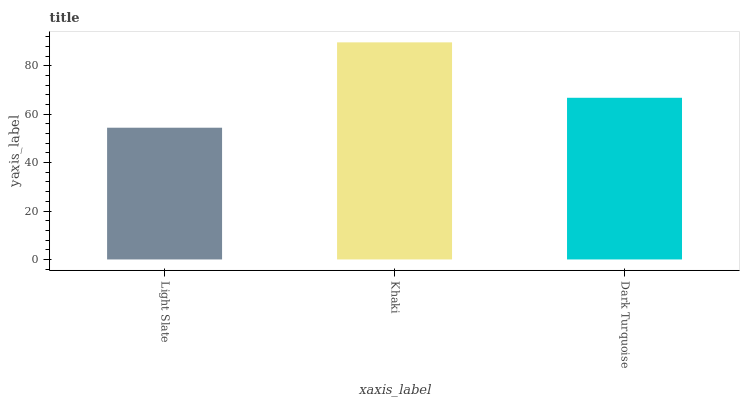Is Light Slate the minimum?
Answer yes or no. Yes. Is Khaki the maximum?
Answer yes or no. Yes. Is Dark Turquoise the minimum?
Answer yes or no. No. Is Dark Turquoise the maximum?
Answer yes or no. No. Is Khaki greater than Dark Turquoise?
Answer yes or no. Yes. Is Dark Turquoise less than Khaki?
Answer yes or no. Yes. Is Dark Turquoise greater than Khaki?
Answer yes or no. No. Is Khaki less than Dark Turquoise?
Answer yes or no. No. Is Dark Turquoise the high median?
Answer yes or no. Yes. Is Dark Turquoise the low median?
Answer yes or no. Yes. Is Light Slate the high median?
Answer yes or no. No. Is Light Slate the low median?
Answer yes or no. No. 